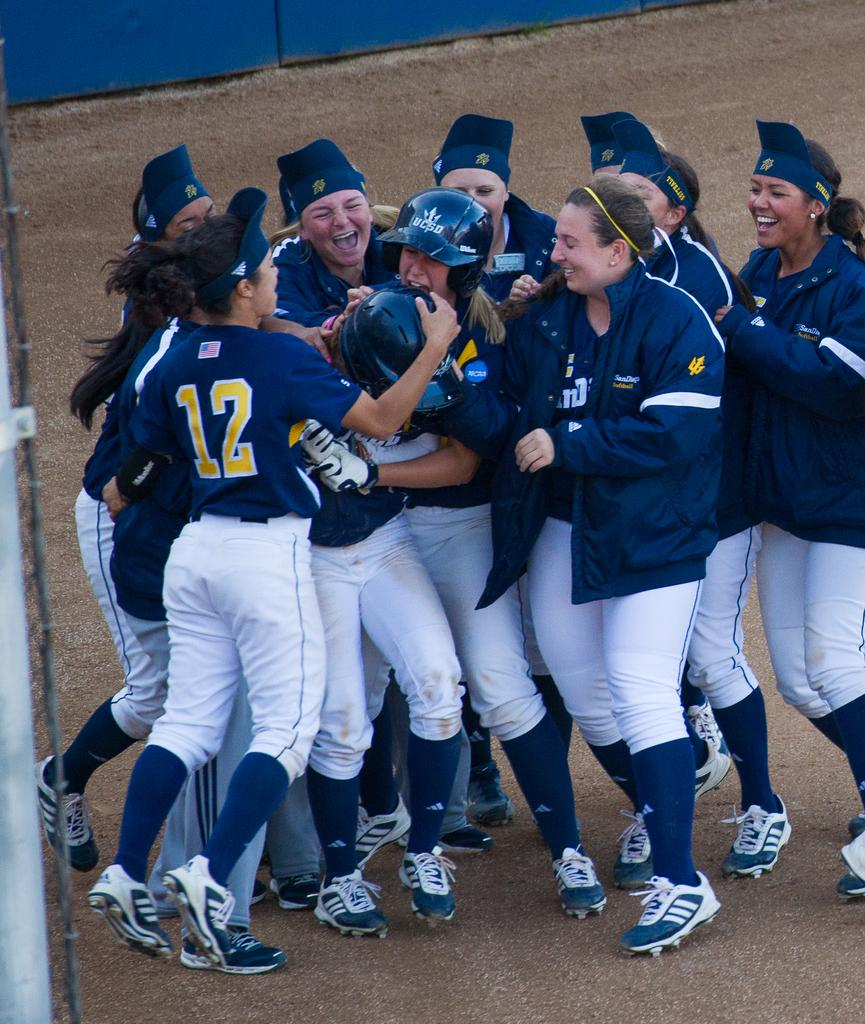What is the main subject of the image? The main subject of the image is a group of women in the foreground. What is the position of the women in the image? The women are on the ground in the image. What can be seen in the background of the image? There is a fence in the background of the image. Can you determine the time of day the image was taken? The image was likely taken during the day, as there is no indication of darkness or artificial lighting. How many chickens are present in the image? There are no chickens present in the image. 